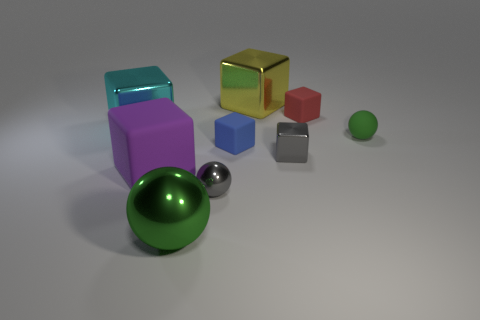Add 1 big purple matte objects. How many objects exist? 10 Subtract all small gray balls. How many balls are left? 2 Subtract all blue blocks. How many green balls are left? 2 Subtract all gray spheres. How many spheres are left? 2 Subtract 2 cubes. How many cubes are left? 4 Subtract 1 green balls. How many objects are left? 8 Subtract all balls. How many objects are left? 6 Subtract all purple cubes. Subtract all yellow spheres. How many cubes are left? 5 Subtract all green shiny blocks. Subtract all cubes. How many objects are left? 3 Add 3 rubber spheres. How many rubber spheres are left? 4 